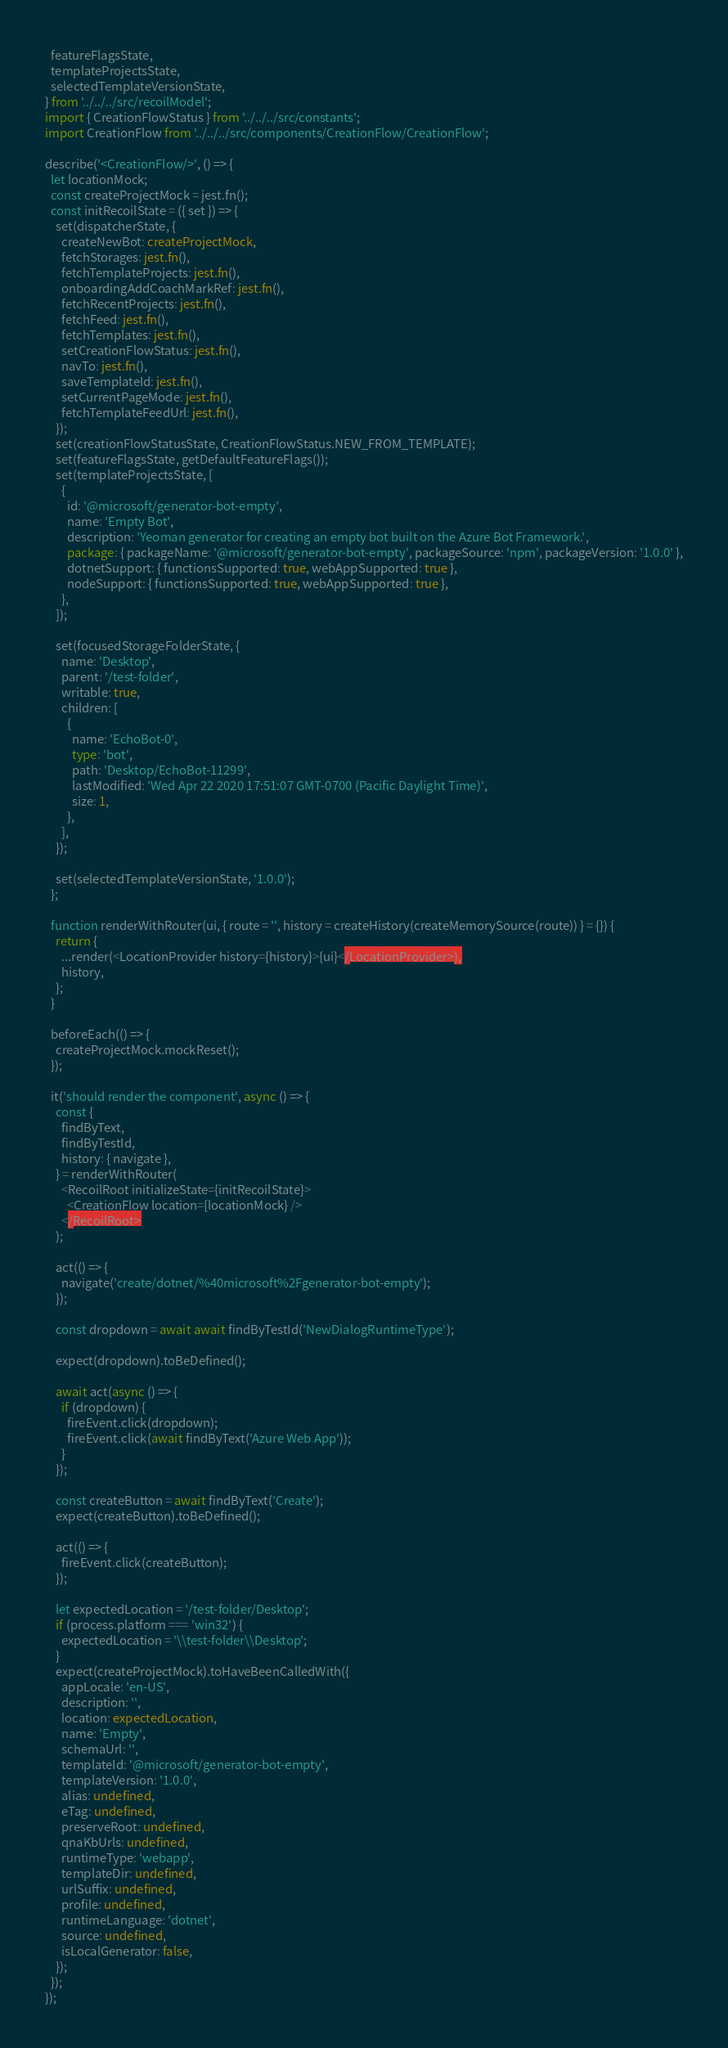<code> <loc_0><loc_0><loc_500><loc_500><_TypeScript_>  featureFlagsState,
  templateProjectsState,
  selectedTemplateVersionState,
} from '../../../src/recoilModel';
import { CreationFlowStatus } from '../../../src/constants';
import CreationFlow from '../../../src/components/CreationFlow/CreationFlow';

describe('<CreationFlow/>', () => {
  let locationMock;
  const createProjectMock = jest.fn();
  const initRecoilState = ({ set }) => {
    set(dispatcherState, {
      createNewBot: createProjectMock,
      fetchStorages: jest.fn(),
      fetchTemplateProjects: jest.fn(),
      onboardingAddCoachMarkRef: jest.fn(),
      fetchRecentProjects: jest.fn(),
      fetchFeed: jest.fn(),
      fetchTemplates: jest.fn(),
      setCreationFlowStatus: jest.fn(),
      navTo: jest.fn(),
      saveTemplateId: jest.fn(),
      setCurrentPageMode: jest.fn(),
      fetchTemplateFeedUrl: jest.fn(),
    });
    set(creationFlowStatusState, CreationFlowStatus.NEW_FROM_TEMPLATE);
    set(featureFlagsState, getDefaultFeatureFlags());
    set(templateProjectsState, [
      {
        id: '@microsoft/generator-bot-empty',
        name: 'Empty Bot',
        description: 'Yeoman generator for creating an empty bot built on the Azure Bot Framework.',
        package: { packageName: '@microsoft/generator-bot-empty', packageSource: 'npm', packageVersion: '1.0.0' },
        dotnetSupport: { functionsSupported: true, webAppSupported: true },
        nodeSupport: { functionsSupported: true, webAppSupported: true },
      },
    ]);

    set(focusedStorageFolderState, {
      name: 'Desktop',
      parent: '/test-folder',
      writable: true,
      children: [
        {
          name: 'EchoBot-0',
          type: 'bot',
          path: 'Desktop/EchoBot-11299',
          lastModified: 'Wed Apr 22 2020 17:51:07 GMT-0700 (Pacific Daylight Time)',
          size: 1,
        },
      ],
    });

    set(selectedTemplateVersionState, '1.0.0');
  };

  function renderWithRouter(ui, { route = '', history = createHistory(createMemorySource(route)) } = {}) {
    return {
      ...render(<LocationProvider history={history}>{ui}</LocationProvider>),
      history,
    };
  }

  beforeEach(() => {
    createProjectMock.mockReset();
  });

  it('should render the component', async () => {
    const {
      findByText,
      findByTestId,
      history: { navigate },
    } = renderWithRouter(
      <RecoilRoot initializeState={initRecoilState}>
        <CreationFlow location={locationMock} />
      </RecoilRoot>
    );

    act(() => {
      navigate('create/dotnet/%40microsoft%2Fgenerator-bot-empty');
    });

    const dropdown = await await findByTestId('NewDialogRuntimeType');

    expect(dropdown).toBeDefined();

    await act(async () => {
      if (dropdown) {
        fireEvent.click(dropdown);
        fireEvent.click(await findByText('Azure Web App'));
      }
    });

    const createButton = await findByText('Create');
    expect(createButton).toBeDefined();

    act(() => {
      fireEvent.click(createButton);
    });

    let expectedLocation = '/test-folder/Desktop';
    if (process.platform === 'win32') {
      expectedLocation = '\\test-folder\\Desktop';
    }
    expect(createProjectMock).toHaveBeenCalledWith({
      appLocale: 'en-US',
      description: '',
      location: expectedLocation,
      name: 'Empty',
      schemaUrl: '',
      templateId: '@microsoft/generator-bot-empty',
      templateVersion: '1.0.0',
      alias: undefined,
      eTag: undefined,
      preserveRoot: undefined,
      qnaKbUrls: undefined,
      runtimeType: 'webapp',
      templateDir: undefined,
      urlSuffix: undefined,
      profile: undefined,
      runtimeLanguage: 'dotnet',
      source: undefined,
      isLocalGenerator: false,
    });
  });
});
</code> 